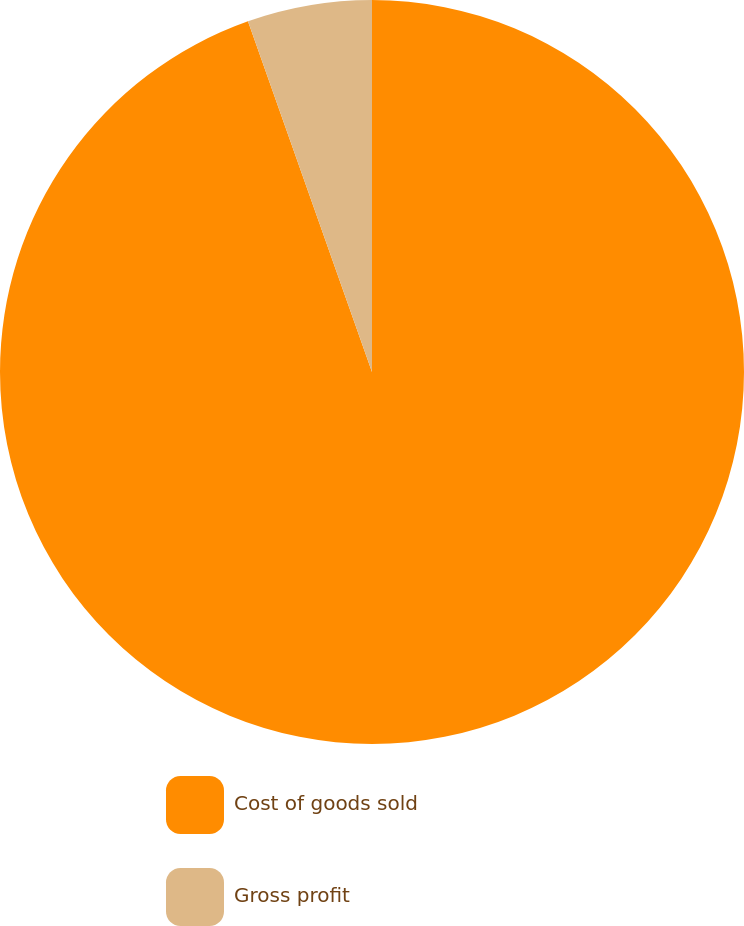Convert chart to OTSL. <chart><loc_0><loc_0><loc_500><loc_500><pie_chart><fcel>Cost of goods sold<fcel>Gross profit<nl><fcel>94.59%<fcel>5.41%<nl></chart> 